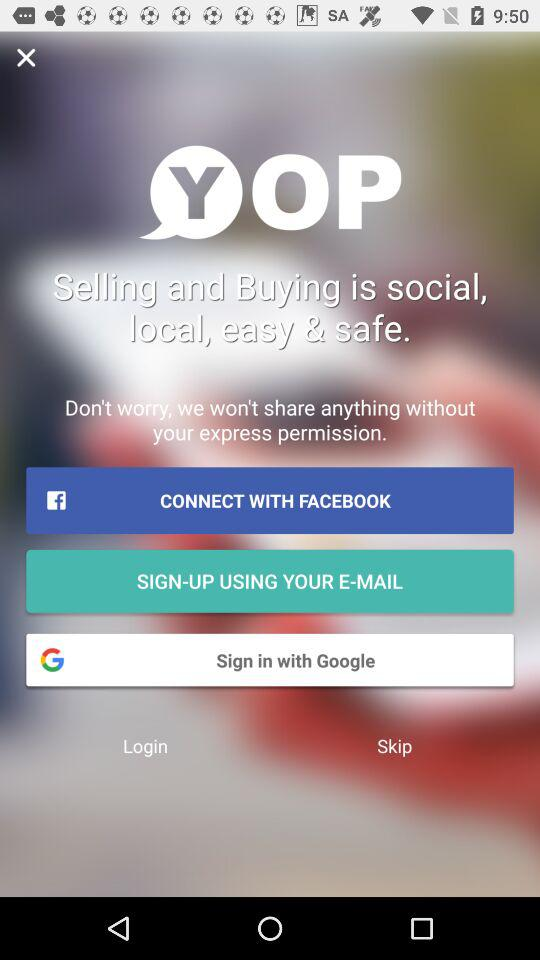Through what application can we connect? You can connect through "FACEBOOK". 